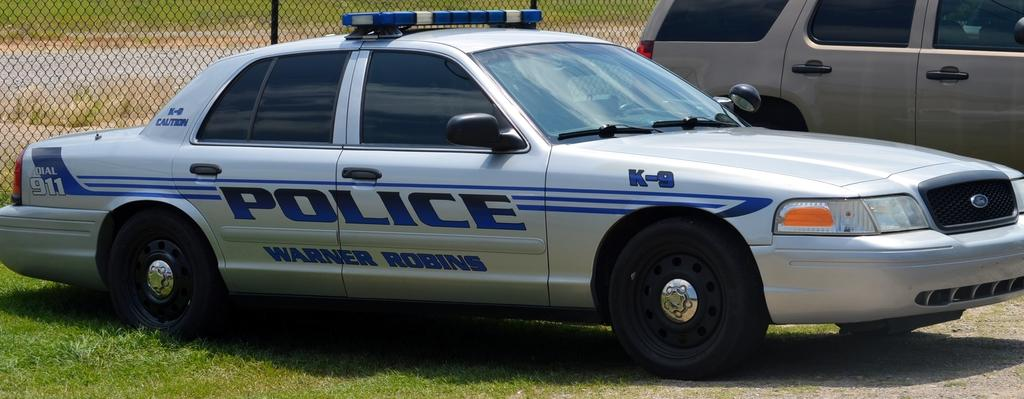How many cars are visible in the image? There are two cars in the image. What type of car is one of them? One of the cars is a police car. What is the other car in the image? The other car is a normal car. What can be seen in the background of the image? There is fencing and grass in the background of the image. What type of vacation is the monkey planning in the image? There is no monkey present in the image, so it is not possible to determine any vacation plans. 